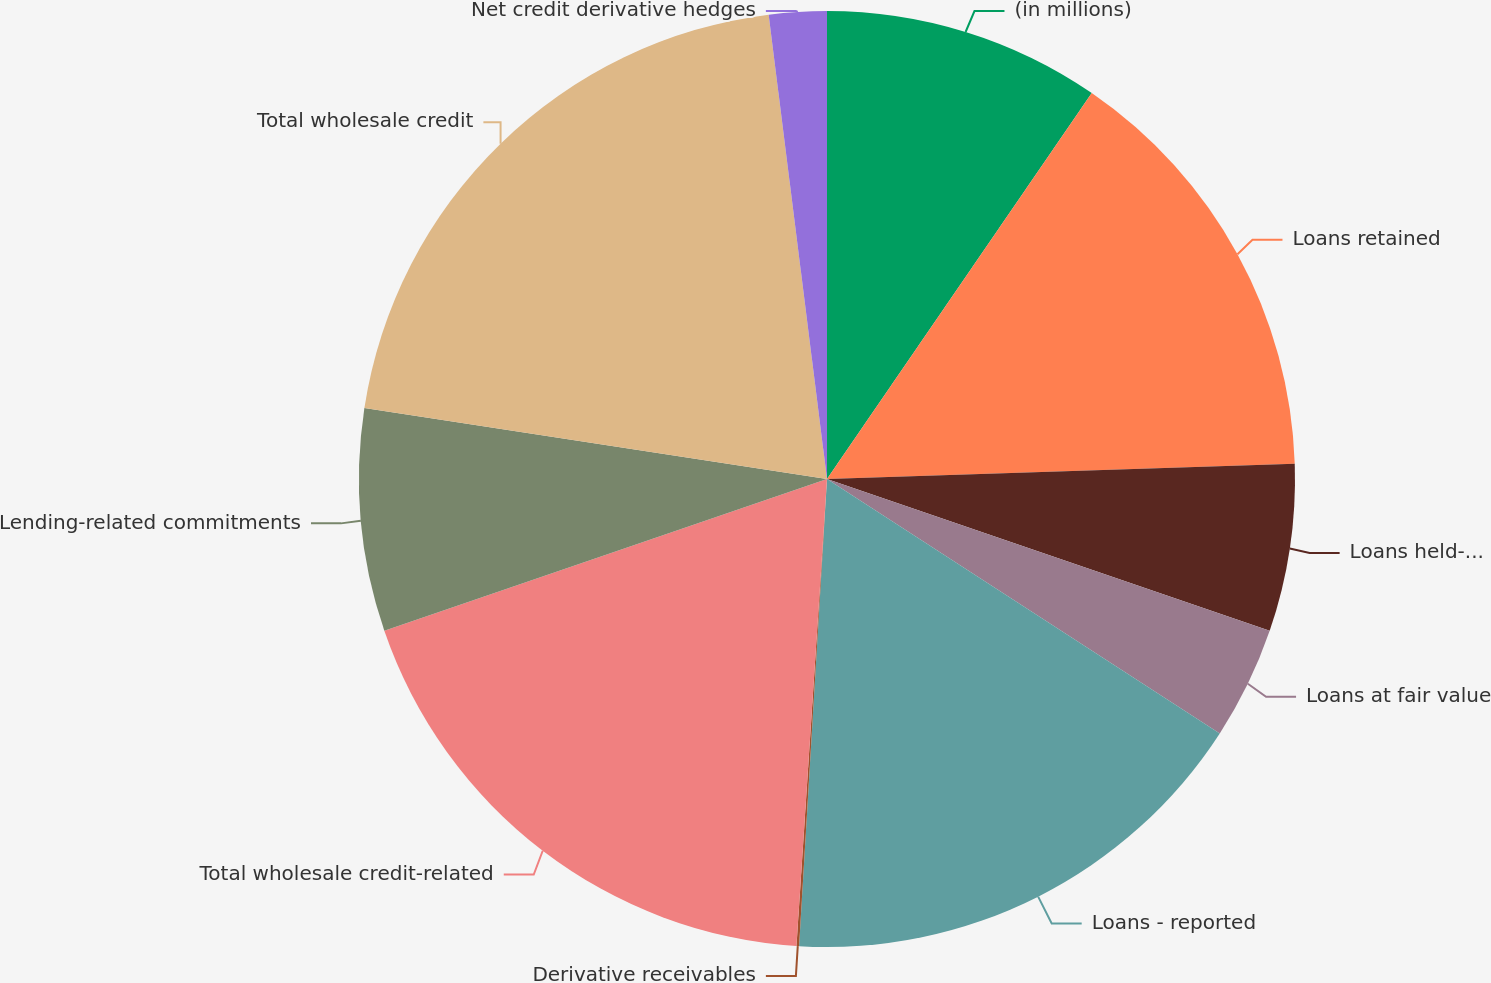<chart> <loc_0><loc_0><loc_500><loc_500><pie_chart><fcel>(in millions)<fcel>Loans retained<fcel>Loans held-for-sale<fcel>Loans at fair value<fcel>Loans - reported<fcel>Derivative receivables<fcel>Total wholesale credit-related<fcel>Lending-related commitments<fcel>Total wholesale credit<fcel>Net credit derivative hedges<nl><fcel>9.57%<fcel>14.91%<fcel>5.78%<fcel>3.89%<fcel>16.8%<fcel>0.09%<fcel>18.7%<fcel>7.68%<fcel>20.59%<fcel>1.99%<nl></chart> 